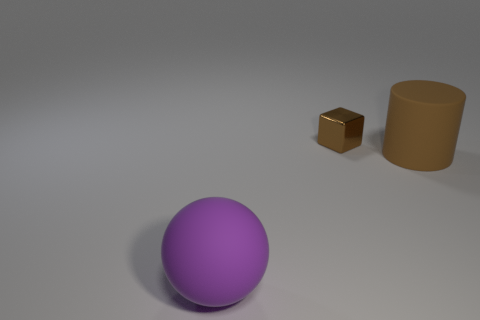Add 1 big blue metallic things. How many objects exist? 4 Subtract all cylinders. How many objects are left? 2 Subtract all large purple spheres. Subtract all tiny blocks. How many objects are left? 1 Add 3 tiny metallic cubes. How many tiny metallic cubes are left? 4 Add 2 big purple metal cylinders. How many big purple metal cylinders exist? 2 Subtract 0 red spheres. How many objects are left? 3 